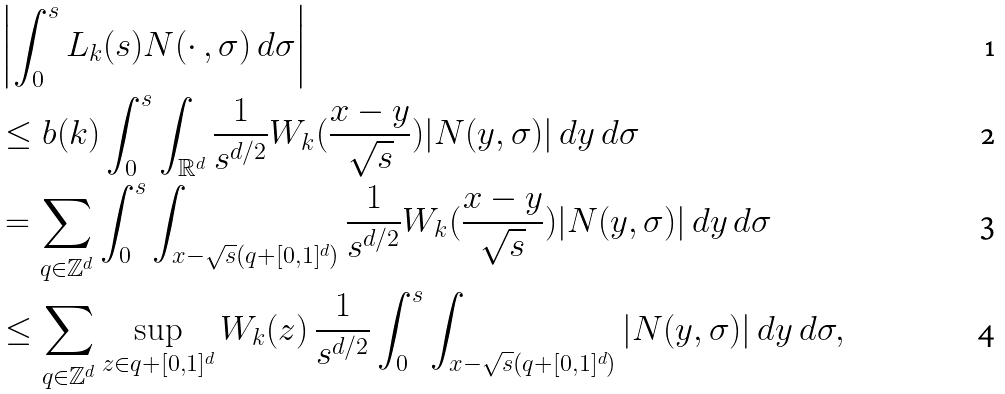<formula> <loc_0><loc_0><loc_500><loc_500>& \left | \int _ { 0 } ^ { s } L _ { k } ( s ) N ( \cdot \, , \sigma ) \, d \sigma \right | \\ & \leq b ( k ) \int _ { 0 } ^ { s } \int _ { { \mathbb { R } } ^ { d } } \frac { 1 } { s ^ { d / 2 } } W _ { k } ( \frac { x - y } { \sqrt { s } } ) | N ( y , \sigma ) | \, d y \, d \sigma \\ & = \sum _ { q \in { \mathbb { Z } } ^ { d } } \int _ { 0 } ^ { s } \int _ { x - \sqrt { s } ( q + [ 0 , 1 ] ^ { d } ) } \frac { 1 } { s ^ { d / 2 } } W _ { k } ( \frac { x - y } { \sqrt { s } } ) | N ( y , \sigma ) | \, d y \, d \sigma \\ & \leq \sum _ { q \in { \mathbb { Z } } ^ { d } } \sup _ { z \in q + [ 0 , 1 ] ^ { d } } W _ { k } ( z ) \, \frac { 1 } { s ^ { d / 2 } } \int _ { 0 } ^ { s } \int _ { x - \sqrt { s } ( q + [ 0 , 1 ] ^ { d } ) } | N ( y , \sigma ) | \, d y \, d \sigma ,</formula> 